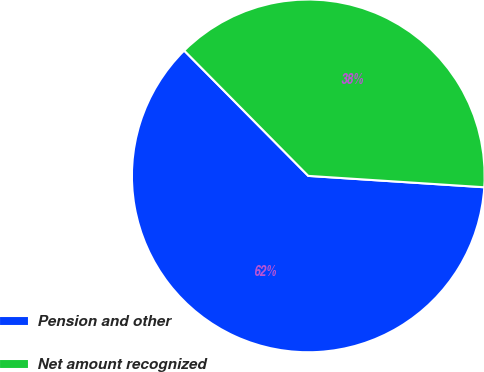<chart> <loc_0><loc_0><loc_500><loc_500><pie_chart><fcel>Pension and other<fcel>Net amount recognized<nl><fcel>61.55%<fcel>38.45%<nl></chart> 